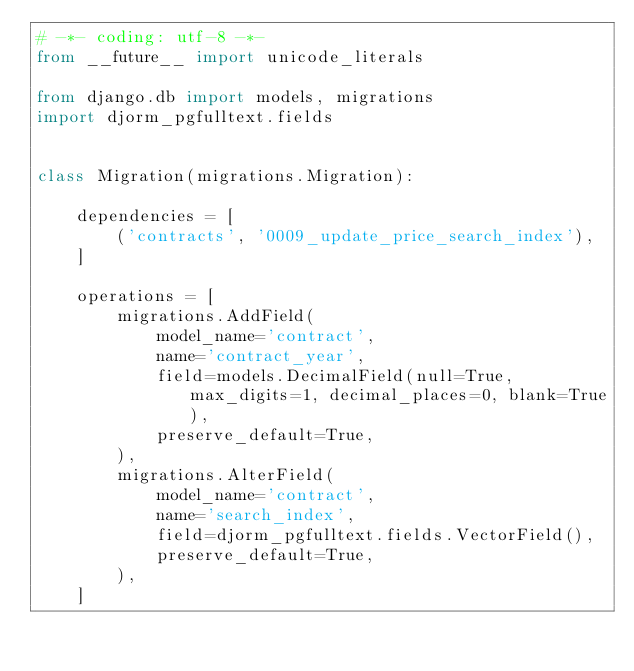Convert code to text. <code><loc_0><loc_0><loc_500><loc_500><_Python_># -*- coding: utf-8 -*-
from __future__ import unicode_literals

from django.db import models, migrations
import djorm_pgfulltext.fields


class Migration(migrations.Migration):

    dependencies = [
        ('contracts', '0009_update_price_search_index'),
    ]

    operations = [
        migrations.AddField(
            model_name='contract',
            name='contract_year',
            field=models.DecimalField(null=True, max_digits=1, decimal_places=0, blank=True),
            preserve_default=True,
        ),
        migrations.AlterField(
            model_name='contract',
            name='search_index',
            field=djorm_pgfulltext.fields.VectorField(),
            preserve_default=True,
        ),
    ]
</code> 